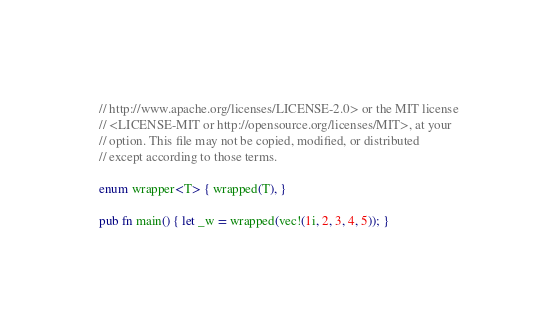<code> <loc_0><loc_0><loc_500><loc_500><_Rust_>// http://www.apache.org/licenses/LICENSE-2.0> or the MIT license
// <LICENSE-MIT or http://opensource.org/licenses/MIT>, at your
// option. This file may not be copied, modified, or distributed
// except according to those terms.

enum wrapper<T> { wrapped(T), }

pub fn main() { let _w = wrapped(vec!(1i, 2, 3, 4, 5)); }
</code> 